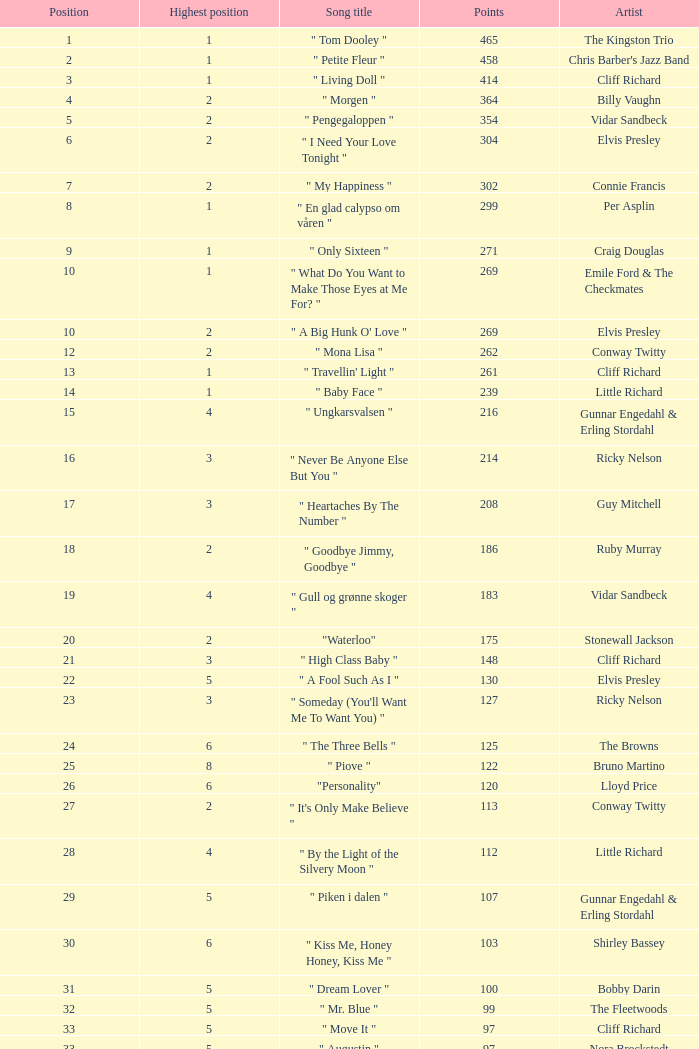What is the nme of the song performed by billy vaughn? " Morgen ". 